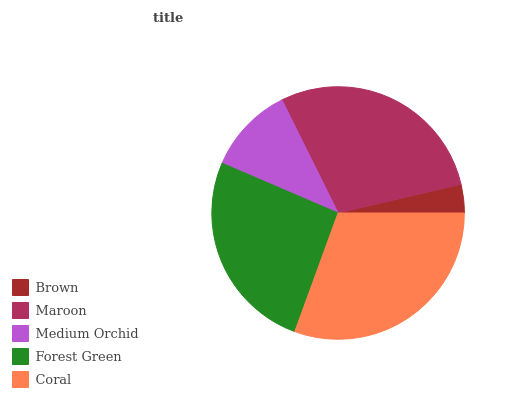Is Brown the minimum?
Answer yes or no. Yes. Is Coral the maximum?
Answer yes or no. Yes. Is Maroon the minimum?
Answer yes or no. No. Is Maroon the maximum?
Answer yes or no. No. Is Maroon greater than Brown?
Answer yes or no. Yes. Is Brown less than Maroon?
Answer yes or no. Yes. Is Brown greater than Maroon?
Answer yes or no. No. Is Maroon less than Brown?
Answer yes or no. No. Is Forest Green the high median?
Answer yes or no. Yes. Is Forest Green the low median?
Answer yes or no. Yes. Is Brown the high median?
Answer yes or no. No. Is Coral the low median?
Answer yes or no. No. 